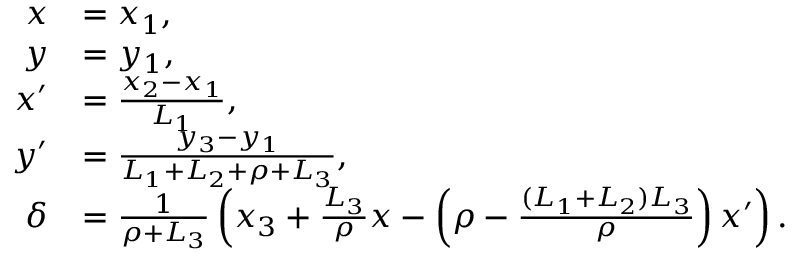<formula> <loc_0><loc_0><loc_500><loc_500>\begin{array} { r l } { x } & { = x _ { 1 } , } \\ { y } & { = y _ { 1 } , } \\ { x ^ { \prime } } & { = \frac { x _ { 2 } - x _ { 1 } } { L _ { 1 } } , } \\ { y ^ { \prime } } & { = \frac { y _ { 3 } - y _ { 1 } } { L _ { 1 } + L _ { 2 } + \rho + L _ { 3 } } , } \\ { \delta } & { = \frac { 1 } { \rho + L _ { 3 } } \left ( x _ { 3 } + \frac { L _ { 3 } } { \rho } x - \left ( { \rho - \frac { ( L _ { 1 } + L _ { 2 } ) L _ { 3 } } { \rho } } \right ) x ^ { \prime } \right ) . } \end{array}</formula> 